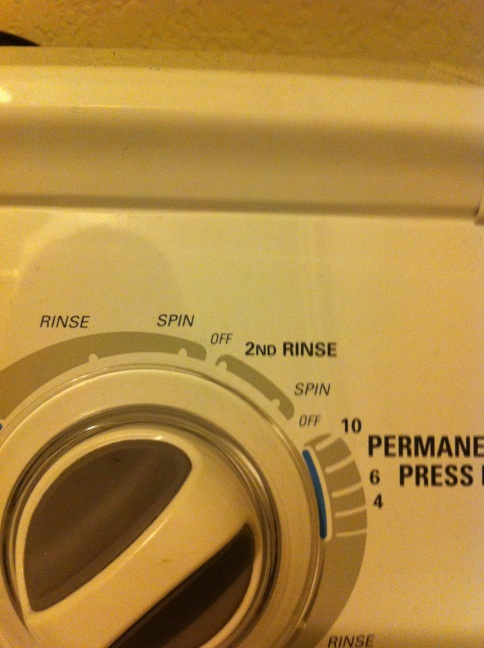Scenario: You have a load of delicate clothes, including a few silk blouses. What setting should you use? For a load of delicate clothes, including silk blouses, you should avoid high-spin settings and prefer a gentle or low-spin cycle, often labeled as 'Delicates' or 'Gentle.' This setting will ensure that your delicate fabrics are washed carefully without causing any damage or excessive wear. It's also good practice to use a protective laundry bag for extra delicate items like silk. 